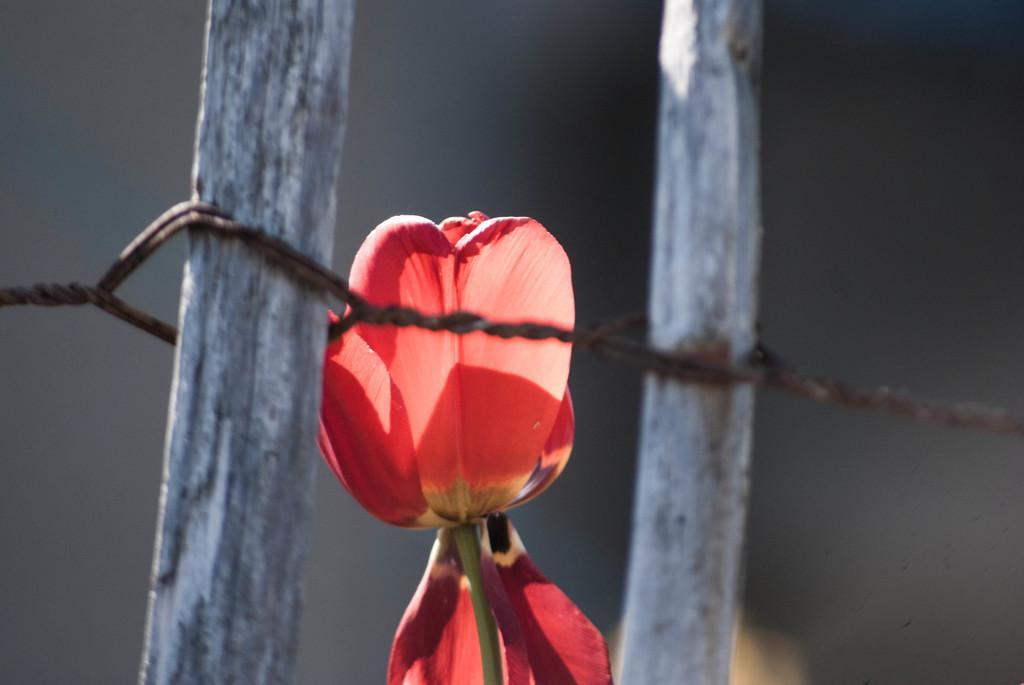Describe this image in one or two sentences. In this image I can see the flower in red color and I can also see two wooden sticks and I can see the wire to it and I can see the dark background. 